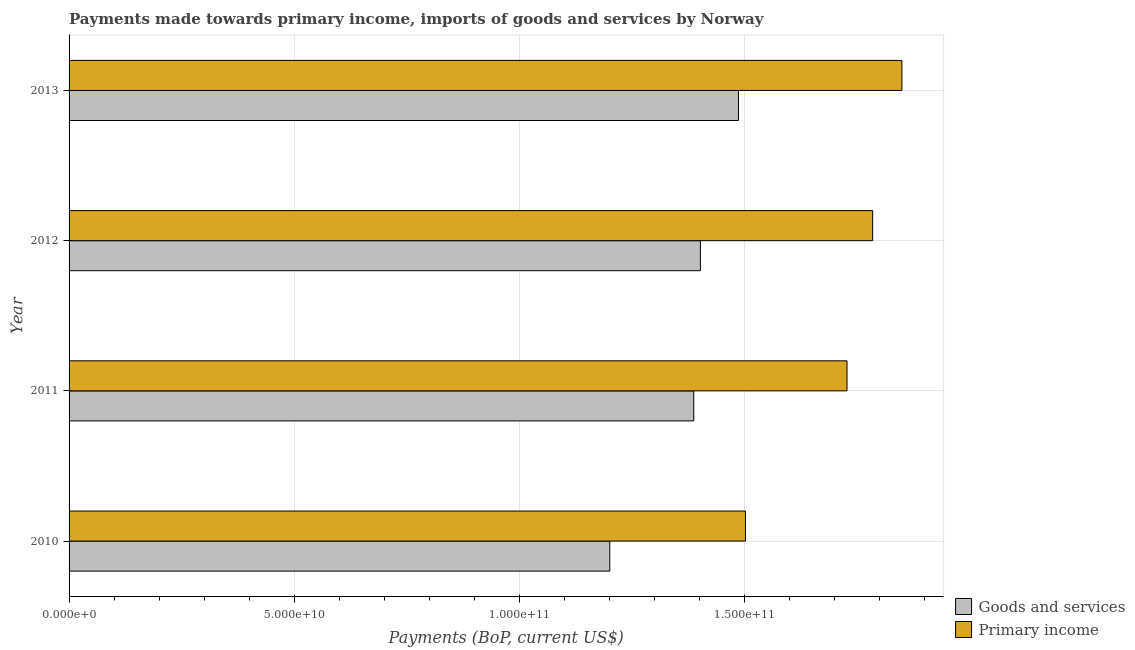How many groups of bars are there?
Your response must be concise. 4. Are the number of bars on each tick of the Y-axis equal?
Provide a succinct answer. Yes. How many bars are there on the 4th tick from the bottom?
Provide a succinct answer. 2. In how many cases, is the number of bars for a given year not equal to the number of legend labels?
Keep it short and to the point. 0. What is the payments made towards goods and services in 2011?
Offer a very short reply. 1.39e+11. Across all years, what is the maximum payments made towards goods and services?
Keep it short and to the point. 1.49e+11. Across all years, what is the minimum payments made towards goods and services?
Make the answer very short. 1.20e+11. In which year was the payments made towards goods and services maximum?
Your answer should be very brief. 2013. What is the total payments made towards primary income in the graph?
Provide a succinct answer. 6.87e+11. What is the difference between the payments made towards primary income in 2011 and that in 2013?
Keep it short and to the point. -1.22e+1. What is the difference between the payments made towards goods and services in 2011 and the payments made towards primary income in 2013?
Offer a very short reply. -4.62e+1. What is the average payments made towards goods and services per year?
Provide a succinct answer. 1.37e+11. In the year 2011, what is the difference between the payments made towards primary income and payments made towards goods and services?
Make the answer very short. 3.40e+1. In how many years, is the payments made towards primary income greater than 80000000000 US$?
Provide a succinct answer. 4. What is the ratio of the payments made towards goods and services in 2010 to that in 2012?
Make the answer very short. 0.86. Is the difference between the payments made towards primary income in 2012 and 2013 greater than the difference between the payments made towards goods and services in 2012 and 2013?
Provide a short and direct response. Yes. What is the difference between the highest and the second highest payments made towards goods and services?
Offer a terse response. 8.45e+09. What is the difference between the highest and the lowest payments made towards goods and services?
Give a very brief answer. 2.86e+1. In how many years, is the payments made towards goods and services greater than the average payments made towards goods and services taken over all years?
Provide a short and direct response. 3. What does the 1st bar from the top in 2012 represents?
Make the answer very short. Primary income. What does the 2nd bar from the bottom in 2011 represents?
Give a very brief answer. Primary income. Are all the bars in the graph horizontal?
Offer a very short reply. Yes. What is the difference between two consecutive major ticks on the X-axis?
Give a very brief answer. 5.00e+1. Does the graph contain any zero values?
Ensure brevity in your answer.  No. Does the graph contain grids?
Your answer should be compact. Yes. How are the legend labels stacked?
Your answer should be very brief. Vertical. What is the title of the graph?
Offer a very short reply. Payments made towards primary income, imports of goods and services by Norway. Does "Agricultural land" appear as one of the legend labels in the graph?
Ensure brevity in your answer.  No. What is the label or title of the X-axis?
Give a very brief answer. Payments (BoP, current US$). What is the label or title of the Y-axis?
Your response must be concise. Year. What is the Payments (BoP, current US$) in Goods and services in 2010?
Your response must be concise. 1.20e+11. What is the Payments (BoP, current US$) in Primary income in 2010?
Offer a terse response. 1.50e+11. What is the Payments (BoP, current US$) in Goods and services in 2011?
Your answer should be compact. 1.39e+11. What is the Payments (BoP, current US$) in Primary income in 2011?
Your answer should be compact. 1.73e+11. What is the Payments (BoP, current US$) of Goods and services in 2012?
Offer a terse response. 1.40e+11. What is the Payments (BoP, current US$) in Primary income in 2012?
Your answer should be compact. 1.79e+11. What is the Payments (BoP, current US$) of Goods and services in 2013?
Keep it short and to the point. 1.49e+11. What is the Payments (BoP, current US$) of Primary income in 2013?
Provide a short and direct response. 1.85e+11. Across all years, what is the maximum Payments (BoP, current US$) of Goods and services?
Give a very brief answer. 1.49e+11. Across all years, what is the maximum Payments (BoP, current US$) in Primary income?
Keep it short and to the point. 1.85e+11. Across all years, what is the minimum Payments (BoP, current US$) in Goods and services?
Ensure brevity in your answer.  1.20e+11. Across all years, what is the minimum Payments (BoP, current US$) in Primary income?
Your answer should be very brief. 1.50e+11. What is the total Payments (BoP, current US$) of Goods and services in the graph?
Your response must be concise. 5.48e+11. What is the total Payments (BoP, current US$) of Primary income in the graph?
Your response must be concise. 6.87e+11. What is the difference between the Payments (BoP, current US$) of Goods and services in 2010 and that in 2011?
Offer a terse response. -1.87e+1. What is the difference between the Payments (BoP, current US$) in Primary income in 2010 and that in 2011?
Provide a succinct answer. -2.26e+1. What is the difference between the Payments (BoP, current US$) in Goods and services in 2010 and that in 2012?
Your response must be concise. -2.01e+1. What is the difference between the Payments (BoP, current US$) in Primary income in 2010 and that in 2012?
Provide a succinct answer. -2.83e+1. What is the difference between the Payments (BoP, current US$) in Goods and services in 2010 and that in 2013?
Your answer should be very brief. -2.86e+1. What is the difference between the Payments (BoP, current US$) of Primary income in 2010 and that in 2013?
Give a very brief answer. -3.48e+1. What is the difference between the Payments (BoP, current US$) in Goods and services in 2011 and that in 2012?
Provide a short and direct response. -1.47e+09. What is the difference between the Payments (BoP, current US$) in Primary income in 2011 and that in 2012?
Give a very brief answer. -5.70e+09. What is the difference between the Payments (BoP, current US$) of Goods and services in 2011 and that in 2013?
Your answer should be compact. -9.93e+09. What is the difference between the Payments (BoP, current US$) of Primary income in 2011 and that in 2013?
Offer a very short reply. -1.22e+1. What is the difference between the Payments (BoP, current US$) in Goods and services in 2012 and that in 2013?
Provide a short and direct response. -8.45e+09. What is the difference between the Payments (BoP, current US$) of Primary income in 2012 and that in 2013?
Provide a short and direct response. -6.50e+09. What is the difference between the Payments (BoP, current US$) in Goods and services in 2010 and the Payments (BoP, current US$) in Primary income in 2011?
Your answer should be compact. -5.27e+1. What is the difference between the Payments (BoP, current US$) of Goods and services in 2010 and the Payments (BoP, current US$) of Primary income in 2012?
Offer a very short reply. -5.84e+1. What is the difference between the Payments (BoP, current US$) in Goods and services in 2010 and the Payments (BoP, current US$) in Primary income in 2013?
Ensure brevity in your answer.  -6.49e+1. What is the difference between the Payments (BoP, current US$) in Goods and services in 2011 and the Payments (BoP, current US$) in Primary income in 2012?
Offer a very short reply. -3.97e+1. What is the difference between the Payments (BoP, current US$) of Goods and services in 2011 and the Payments (BoP, current US$) of Primary income in 2013?
Provide a short and direct response. -4.62e+1. What is the difference between the Payments (BoP, current US$) in Goods and services in 2012 and the Payments (BoP, current US$) in Primary income in 2013?
Ensure brevity in your answer.  -4.48e+1. What is the average Payments (BoP, current US$) in Goods and services per year?
Offer a terse response. 1.37e+11. What is the average Payments (BoP, current US$) in Primary income per year?
Provide a short and direct response. 1.72e+11. In the year 2010, what is the difference between the Payments (BoP, current US$) of Goods and services and Payments (BoP, current US$) of Primary income?
Your answer should be compact. -3.01e+1. In the year 2011, what is the difference between the Payments (BoP, current US$) of Goods and services and Payments (BoP, current US$) of Primary income?
Keep it short and to the point. -3.40e+1. In the year 2012, what is the difference between the Payments (BoP, current US$) in Goods and services and Payments (BoP, current US$) in Primary income?
Offer a very short reply. -3.83e+1. In the year 2013, what is the difference between the Payments (BoP, current US$) of Goods and services and Payments (BoP, current US$) of Primary income?
Provide a succinct answer. -3.63e+1. What is the ratio of the Payments (BoP, current US$) in Goods and services in 2010 to that in 2011?
Your response must be concise. 0.87. What is the ratio of the Payments (BoP, current US$) of Primary income in 2010 to that in 2011?
Keep it short and to the point. 0.87. What is the ratio of the Payments (BoP, current US$) of Goods and services in 2010 to that in 2012?
Your answer should be compact. 0.86. What is the ratio of the Payments (BoP, current US$) of Primary income in 2010 to that in 2012?
Ensure brevity in your answer.  0.84. What is the ratio of the Payments (BoP, current US$) in Goods and services in 2010 to that in 2013?
Your answer should be very brief. 0.81. What is the ratio of the Payments (BoP, current US$) in Primary income in 2010 to that in 2013?
Offer a terse response. 0.81. What is the ratio of the Payments (BoP, current US$) in Goods and services in 2011 to that in 2012?
Give a very brief answer. 0.99. What is the ratio of the Payments (BoP, current US$) in Primary income in 2011 to that in 2012?
Offer a terse response. 0.97. What is the ratio of the Payments (BoP, current US$) in Goods and services in 2011 to that in 2013?
Your answer should be very brief. 0.93. What is the ratio of the Payments (BoP, current US$) in Primary income in 2011 to that in 2013?
Keep it short and to the point. 0.93. What is the ratio of the Payments (BoP, current US$) in Goods and services in 2012 to that in 2013?
Make the answer very short. 0.94. What is the ratio of the Payments (BoP, current US$) of Primary income in 2012 to that in 2013?
Provide a succinct answer. 0.96. What is the difference between the highest and the second highest Payments (BoP, current US$) of Goods and services?
Offer a very short reply. 8.45e+09. What is the difference between the highest and the second highest Payments (BoP, current US$) of Primary income?
Keep it short and to the point. 6.50e+09. What is the difference between the highest and the lowest Payments (BoP, current US$) of Goods and services?
Make the answer very short. 2.86e+1. What is the difference between the highest and the lowest Payments (BoP, current US$) in Primary income?
Make the answer very short. 3.48e+1. 